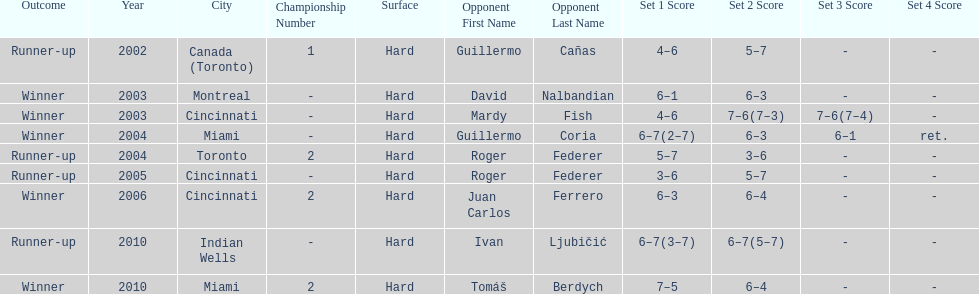Was roddick a runner-up or winner more? Winner. 